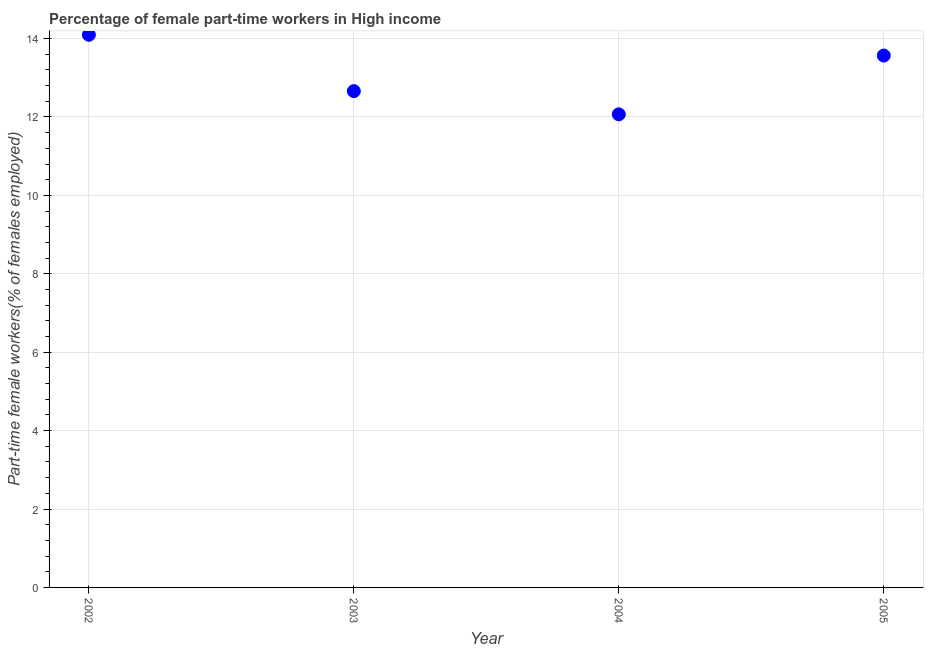What is the percentage of part-time female workers in 2005?
Offer a very short reply. 13.57. Across all years, what is the maximum percentage of part-time female workers?
Give a very brief answer. 14.1. Across all years, what is the minimum percentage of part-time female workers?
Provide a short and direct response. 12.07. In which year was the percentage of part-time female workers minimum?
Give a very brief answer. 2004. What is the sum of the percentage of part-time female workers?
Make the answer very short. 52.39. What is the difference between the percentage of part-time female workers in 2004 and 2005?
Your response must be concise. -1.5. What is the average percentage of part-time female workers per year?
Ensure brevity in your answer.  13.1. What is the median percentage of part-time female workers?
Offer a terse response. 13.11. In how many years, is the percentage of part-time female workers greater than 9.6 %?
Keep it short and to the point. 4. What is the ratio of the percentage of part-time female workers in 2002 to that in 2003?
Offer a very short reply. 1.11. What is the difference between the highest and the second highest percentage of part-time female workers?
Make the answer very short. 0.53. What is the difference between the highest and the lowest percentage of part-time female workers?
Your response must be concise. 2.03. How many dotlines are there?
Ensure brevity in your answer.  1. What is the difference between two consecutive major ticks on the Y-axis?
Offer a very short reply. 2. Does the graph contain any zero values?
Keep it short and to the point. No. Does the graph contain grids?
Keep it short and to the point. Yes. What is the title of the graph?
Keep it short and to the point. Percentage of female part-time workers in High income. What is the label or title of the Y-axis?
Provide a succinct answer. Part-time female workers(% of females employed). What is the Part-time female workers(% of females employed) in 2002?
Your response must be concise. 14.1. What is the Part-time female workers(% of females employed) in 2003?
Your answer should be very brief. 12.66. What is the Part-time female workers(% of females employed) in 2004?
Make the answer very short. 12.07. What is the Part-time female workers(% of females employed) in 2005?
Make the answer very short. 13.57. What is the difference between the Part-time female workers(% of females employed) in 2002 and 2003?
Make the answer very short. 1.44. What is the difference between the Part-time female workers(% of females employed) in 2002 and 2004?
Your answer should be compact. 2.03. What is the difference between the Part-time female workers(% of females employed) in 2002 and 2005?
Offer a terse response. 0.53. What is the difference between the Part-time female workers(% of females employed) in 2003 and 2004?
Your answer should be compact. 0.59. What is the difference between the Part-time female workers(% of females employed) in 2003 and 2005?
Provide a succinct answer. -0.91. What is the difference between the Part-time female workers(% of females employed) in 2004 and 2005?
Provide a succinct answer. -1.5. What is the ratio of the Part-time female workers(% of females employed) in 2002 to that in 2003?
Offer a very short reply. 1.11. What is the ratio of the Part-time female workers(% of females employed) in 2002 to that in 2004?
Ensure brevity in your answer.  1.17. What is the ratio of the Part-time female workers(% of females employed) in 2002 to that in 2005?
Your answer should be compact. 1.04. What is the ratio of the Part-time female workers(% of females employed) in 2003 to that in 2004?
Provide a succinct answer. 1.05. What is the ratio of the Part-time female workers(% of females employed) in 2003 to that in 2005?
Ensure brevity in your answer.  0.93. What is the ratio of the Part-time female workers(% of females employed) in 2004 to that in 2005?
Your response must be concise. 0.89. 